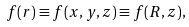Convert formula to latex. <formula><loc_0><loc_0><loc_500><loc_500>f ( r ) \equiv f ( x , y , z ) \equiv f ( R , z ) ,</formula> 